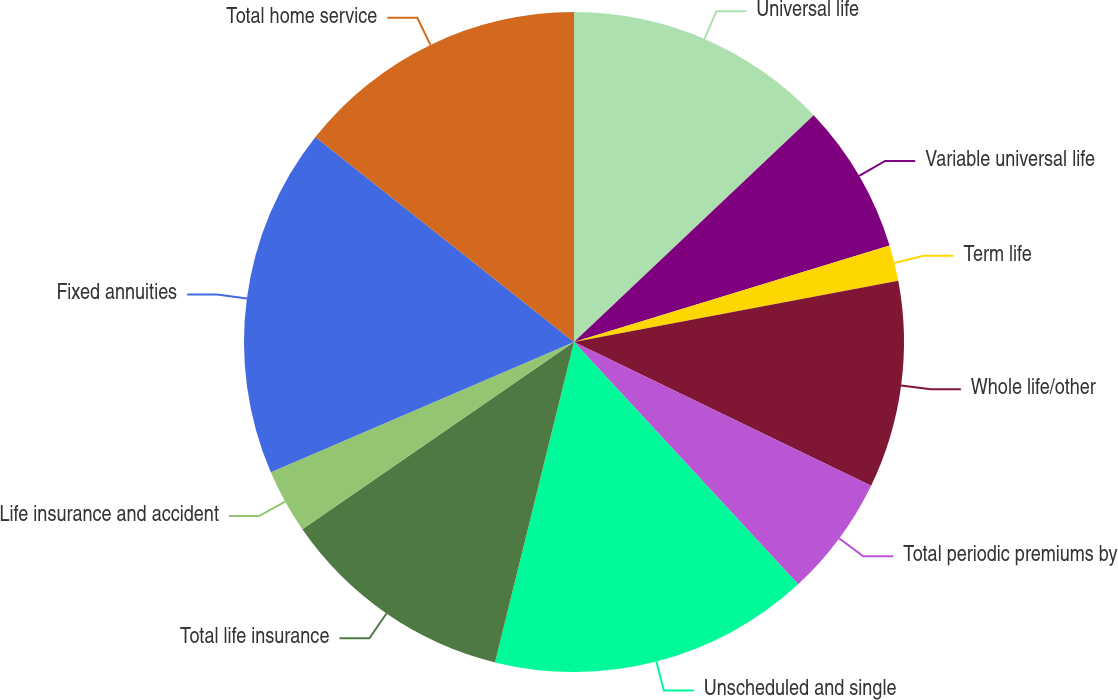Convert chart. <chart><loc_0><loc_0><loc_500><loc_500><pie_chart><fcel>Universal life<fcel>Variable universal life<fcel>Term life<fcel>Whole life/other<fcel>Total periodic premiums by<fcel>Unscheduled and single<fcel>Total life insurance<fcel>Life insurance and accident<fcel>Fixed annuities<fcel>Total home service<nl><fcel>12.94%<fcel>7.34%<fcel>1.75%<fcel>10.14%<fcel>5.95%<fcel>15.73%<fcel>11.54%<fcel>3.15%<fcel>17.13%<fcel>14.33%<nl></chart> 